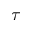<formula> <loc_0><loc_0><loc_500><loc_500>\tau</formula> 